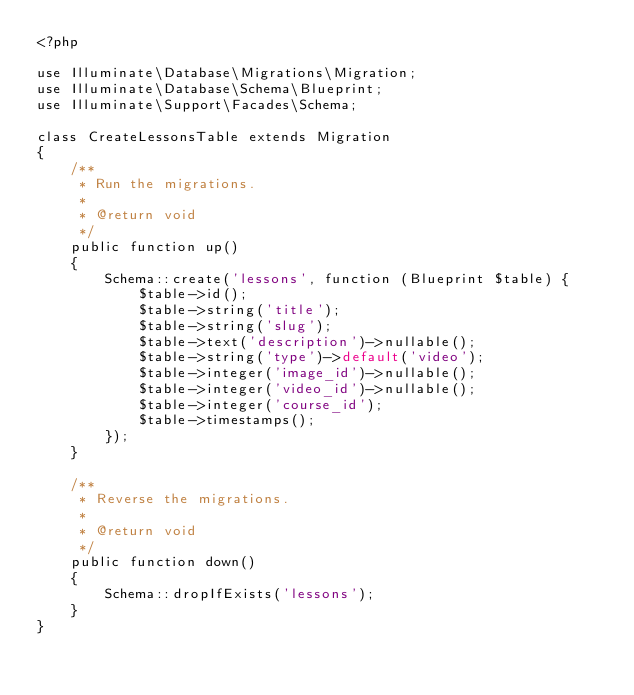Convert code to text. <code><loc_0><loc_0><loc_500><loc_500><_PHP_><?php

use Illuminate\Database\Migrations\Migration;
use Illuminate\Database\Schema\Blueprint;
use Illuminate\Support\Facades\Schema;

class CreateLessonsTable extends Migration
{
    /**
     * Run the migrations.
     *
     * @return void
     */
    public function up()
    {
        Schema::create('lessons', function (Blueprint $table) {
            $table->id();
            $table->string('title');
            $table->string('slug');
            $table->text('description')->nullable();
            $table->string('type')->default('video');
            $table->integer('image_id')->nullable();
            $table->integer('video_id')->nullable();
            $table->integer('course_id');
            $table->timestamps();
        });
    }

    /**
     * Reverse the migrations.
     *
     * @return void
     */
    public function down()
    {
        Schema::dropIfExists('lessons');
    }
}
</code> 